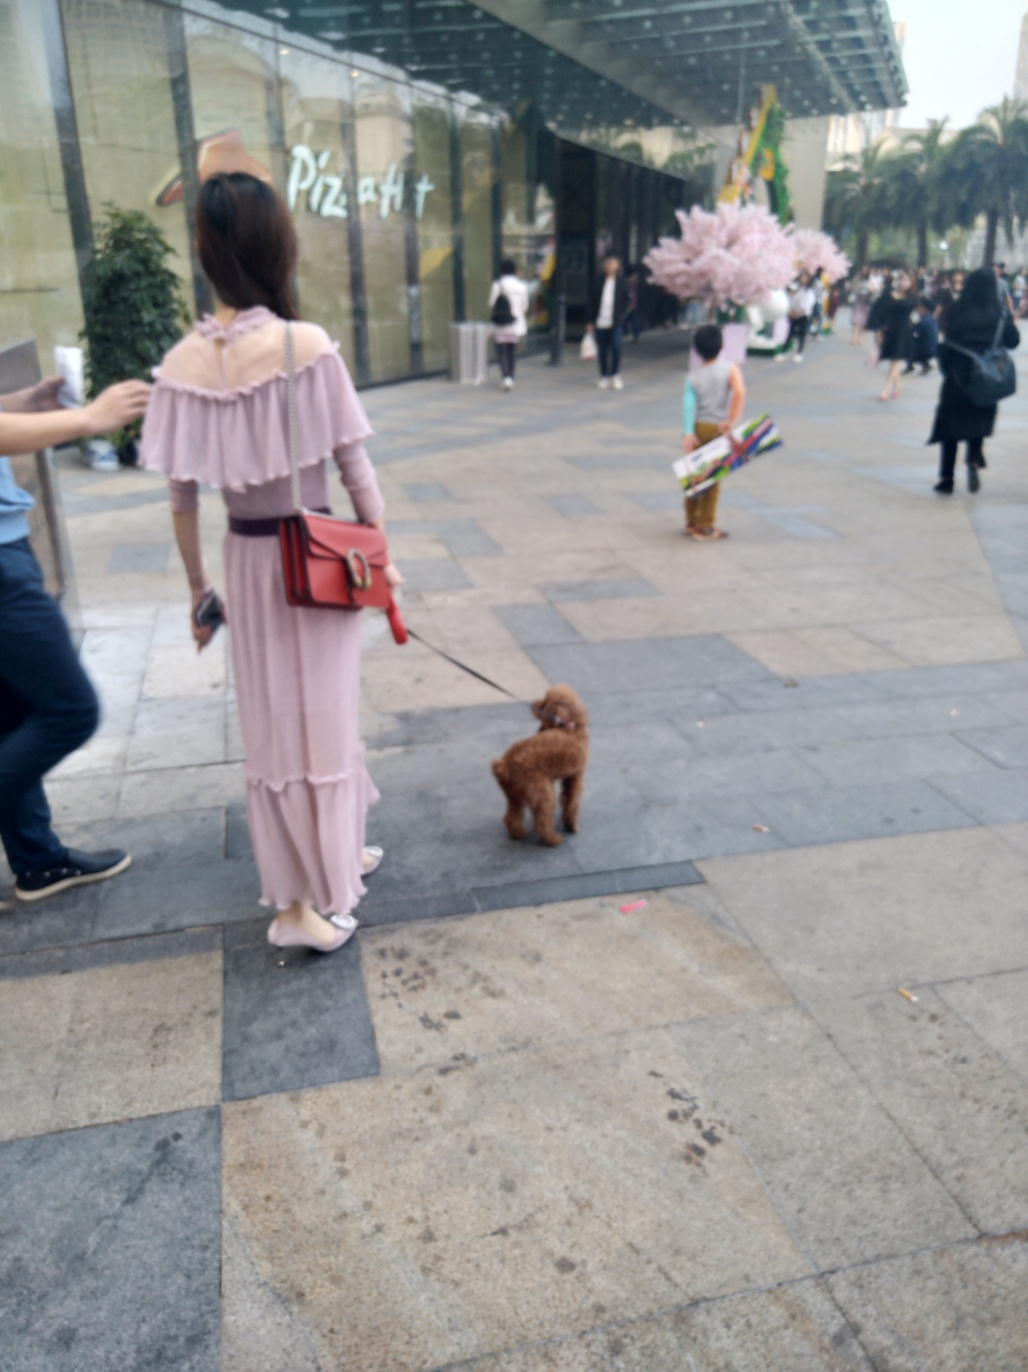What is the approximate time of day in this image? The image gives the impression of a time either in the late afternoon or early evening. This is suggested by the softness of the light and the length of the shadows, which are present but not overly elongated. 